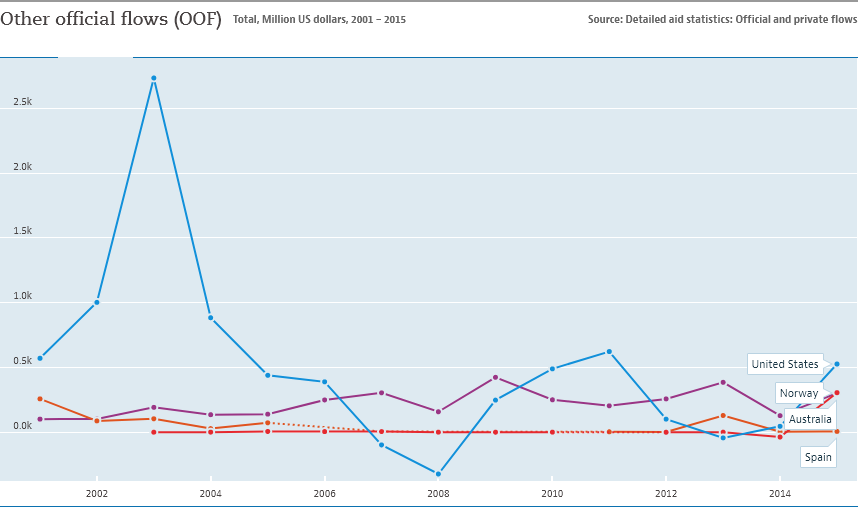Highlight a few significant elements in this photo. The United States has achieved the highest number of official flows in the timeline. Australia had the lowest variation in official flows between 2004 and 2006 compared to the other countries. 